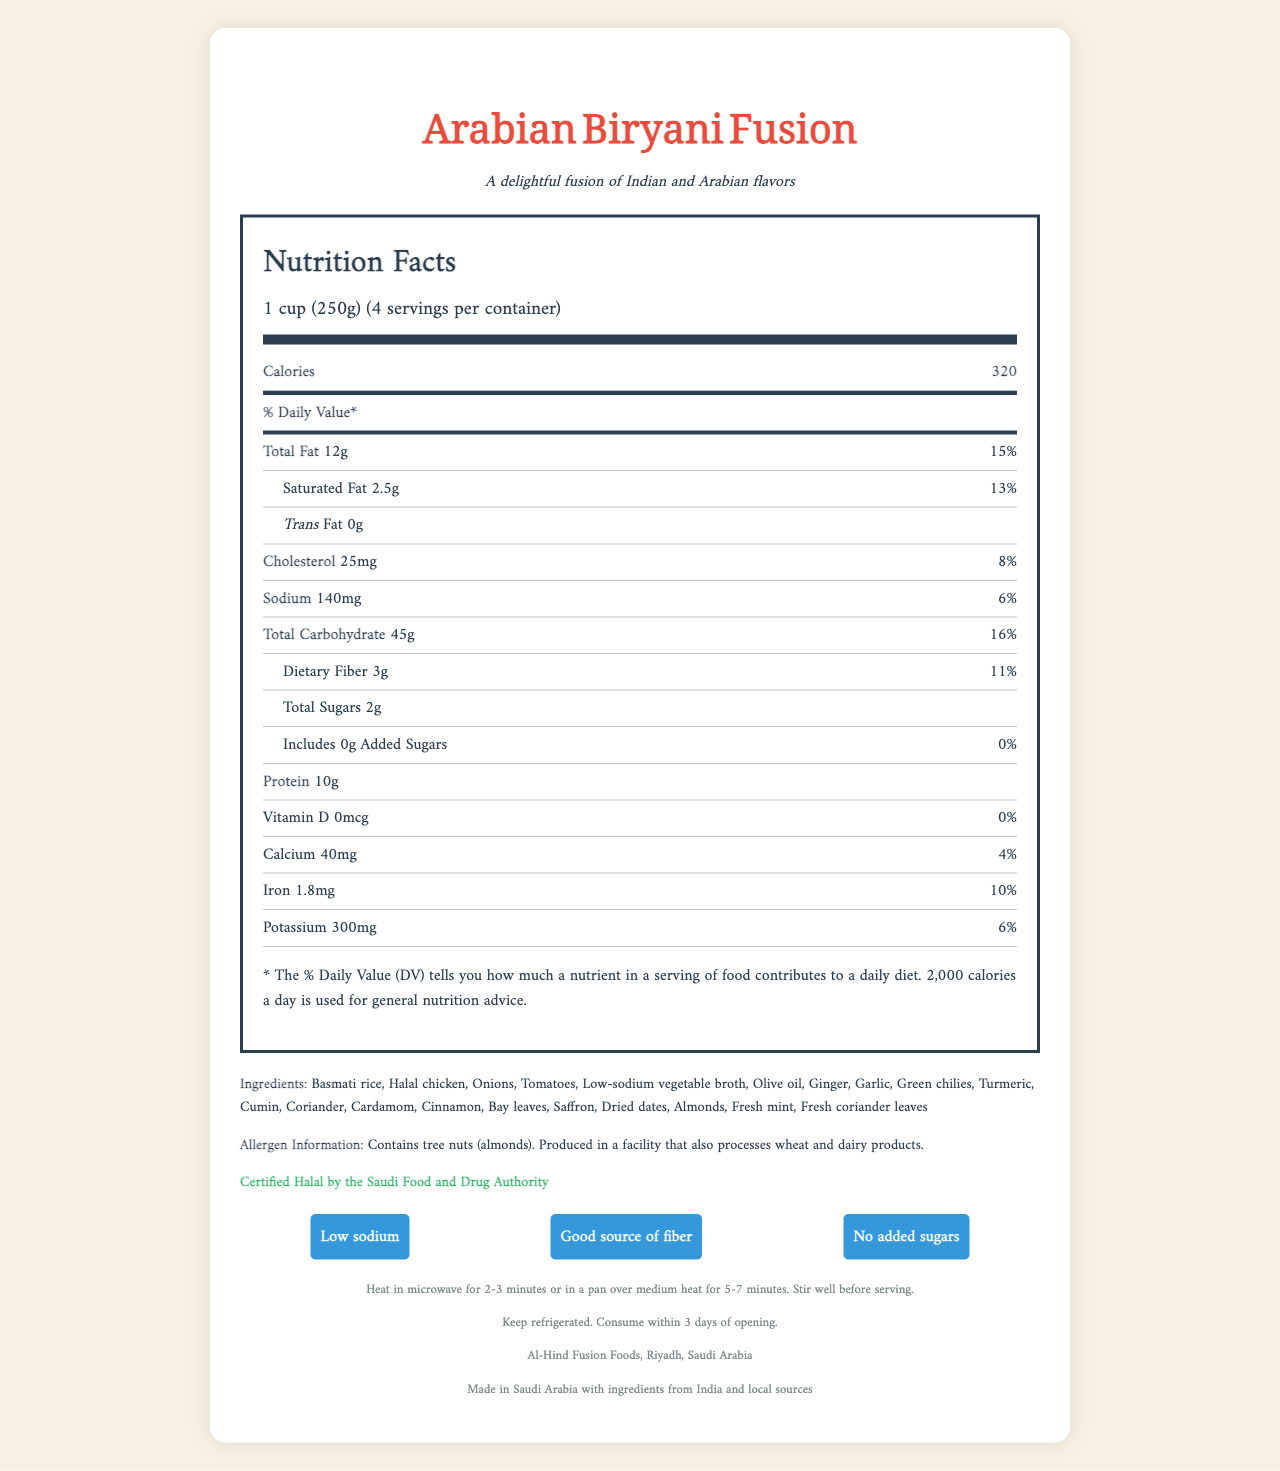what is the serving size? The serving size is clearly mentioned under the nutrition facts heading as 1 cup (250g).
Answer: 1 cup (250g) how many calories are in one serving? The calories per serving are listed under the nutrition facts as 320.
Answer: 320 what is the amount of sodium per serving? The sodium content per serving is listed as 140mg.
Answer: 140mg how many servings are in one container? The number of servings per container is stated as 4.
Answer: 4 is the product certified halal? The document indicates that the product is certified Halal by the Saudi Food and Drug Authority.
Answer: Yes what percentage of the daily value of iron does one serving of this product provide? The iron content is listed as 1.8mg, which is 10% of the daily value.
Answer: 10% how much dietary fiber is in one serving? The dietary fiber content per serving is 3g.
Answer: 3g what is the ingredient list for the Arabian Biryani Fusion? All ingredients are listed under the ingredients section.
Answer: Basmati rice, Halal chicken, Onions, Tomatoes, Low-sodium vegetable broth, Olive oil, Ginger, Garlic, Green chilies, Turmeric, Cumin, Coriander, Cardamom, Cinnamon, Bay leaves, Saffron, Dried dates, Almonds, Fresh mint, Fresh coriander leaves which piece of information about added sugars is true? 1. Contains 5g of added sugars per serving 2. Contains 0g of added sugars per serving 3. Contains 2g of added sugars per serving The label shows includes 0g Added Sugars with a daily value of 0%, indicating that the product contains 0g of added sugars.
Answer: 2 what is the % daily value of total fat in one serving? A. 20% B. 25% C. 15% D. 10% The total fat content is listed as 12g, which is 15% of the daily value.
Answer: C how many grams of protein are in one serving? The protein content per serving is listed as 10g.
Answer: 10g is there any trans fat in this product? The label clearly states that the trans fat content is 0g.
Answer: No does the product contain tree nuts? The allergen information indicates that the product contains tree nuts (almonds).
Answer: Yes what are the preparation instructions for the Arabian Biryani Fusion? The preparation instructions are listed as heat in microwave for 2-3 minutes or in a pan over medium heat for 5-7 minutes, stirring well before serving.
Answer: Heat in microwave for 2-3 minutes or in a pan over medium heat for 5-7 minutes. Stir well before serving. what is the main health claim about sodium content of this dish? The health claims section clearly mentions "Low sodium" as a health claim.
Answer: Low sodium who is the manufacturer of this product? The manufacturer's information is listed as Al-Hind Fusion Foods, Riyadh, Saudi Arabia.
Answer: Al-Hind Fusion Foods, Riyadh, Saudi Arabia what is the main idea of the document? The document includes detailed sections on nutrition facts, ingredients, allergen information, preparation, storage instructions, manufacturer, and product origin, with specific emphasis on health claims and cultural certification.
Answer: The document provides nutritional information, ingredients, and other relevant details about the Arabian Biryani Fusion, emphasizing its low-sodium content, halal certification, and fusion of Indian and Arabian flavors. which vitamin does the product not contain? The nutrition facts show that the product contains 0mcg of Vitamin D, indicating it does not contain this vitamin.
Answer: Vitamin D how many calories should a general daily diet be based on according to the footnote in the nutrition facts section? The footnote mentions that 2,000 calories a day is used for general nutrition advice.
Answer: 2,000 calories where are the ingredients sourced from? The product origin section indicates that the ingredients are sourced from India and locally in Saudi Arabia.
Answer: India and local sources in Saudi Arabia how long can the product be stored after opening? The storage instructions state to keep refrigerated and consume within 3 days of opening.
Answer: Consume within 3 days of opening. what is the significance of the daily value percentages listed in the document? The footnote explains that the % Daily Value helps to understand the contribution of each nutrient to a daily diet.
Answer: The % Daily Value (DV) indicates how much a nutrient in a serving of food contributes to a daily diet. 